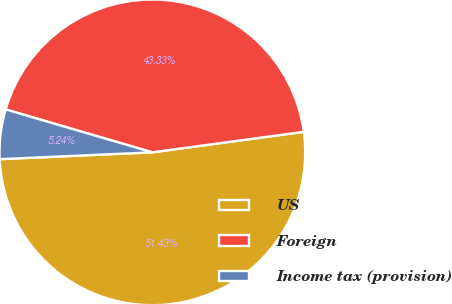Convert chart to OTSL. <chart><loc_0><loc_0><loc_500><loc_500><pie_chart><fcel>US<fcel>Foreign<fcel>Income tax (provision)<nl><fcel>51.43%<fcel>43.33%<fcel>5.24%<nl></chart> 